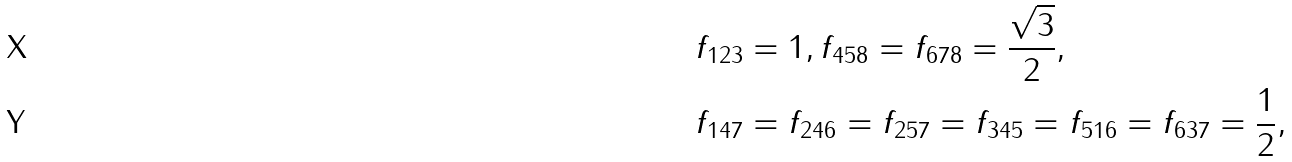<formula> <loc_0><loc_0><loc_500><loc_500>f _ { 1 2 3 } & = 1 , f _ { 4 5 8 } = f _ { 6 7 8 } = \frac { \sqrt { 3 } } { 2 } , \\ f _ { 1 4 7 } & = f _ { 2 4 6 } = f _ { 2 5 7 } = f _ { 3 4 5 } = f _ { 5 1 6 } = f _ { 6 3 7 } = \frac { 1 } { 2 } ,</formula> 